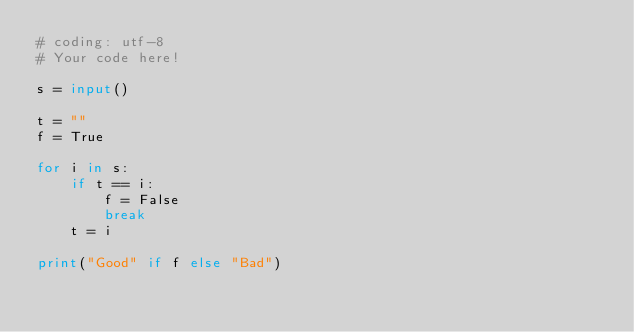<code> <loc_0><loc_0><loc_500><loc_500><_Python_># coding: utf-8
# Your code here!

s = input()

t = ""
f = True

for i in s:
    if t == i:
        f = False
        break
    t = i

print("Good" if f else "Bad")</code> 